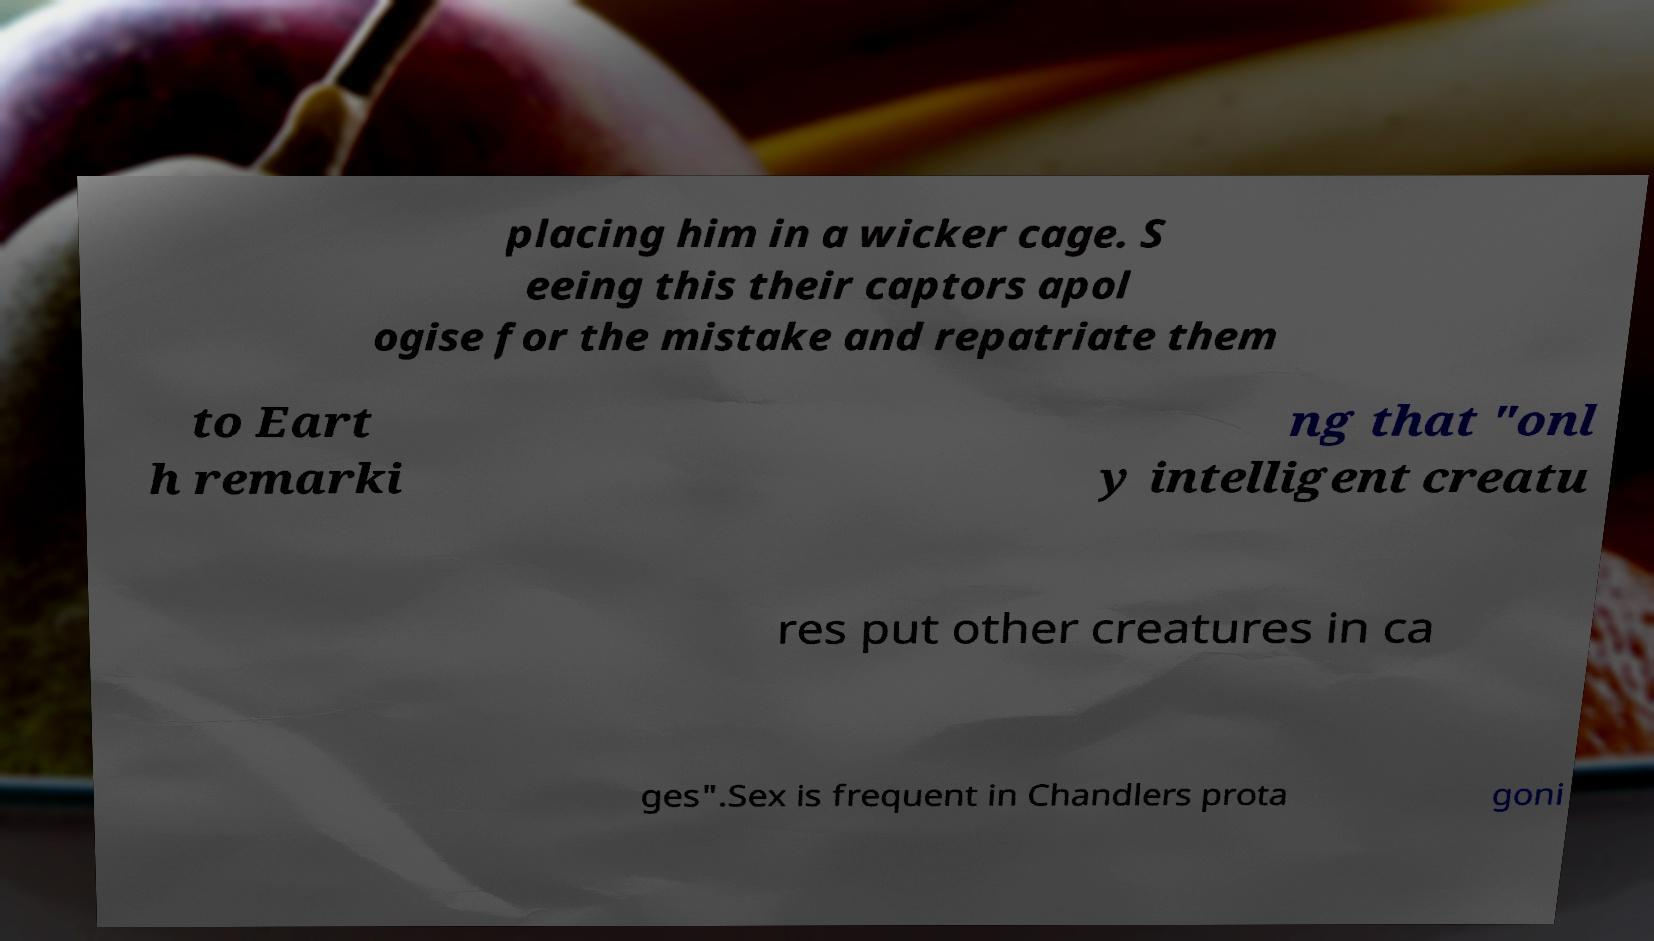Can you accurately transcribe the text from the provided image for me? placing him in a wicker cage. S eeing this their captors apol ogise for the mistake and repatriate them to Eart h remarki ng that "onl y intelligent creatu res put other creatures in ca ges".Sex is frequent in Chandlers prota goni 